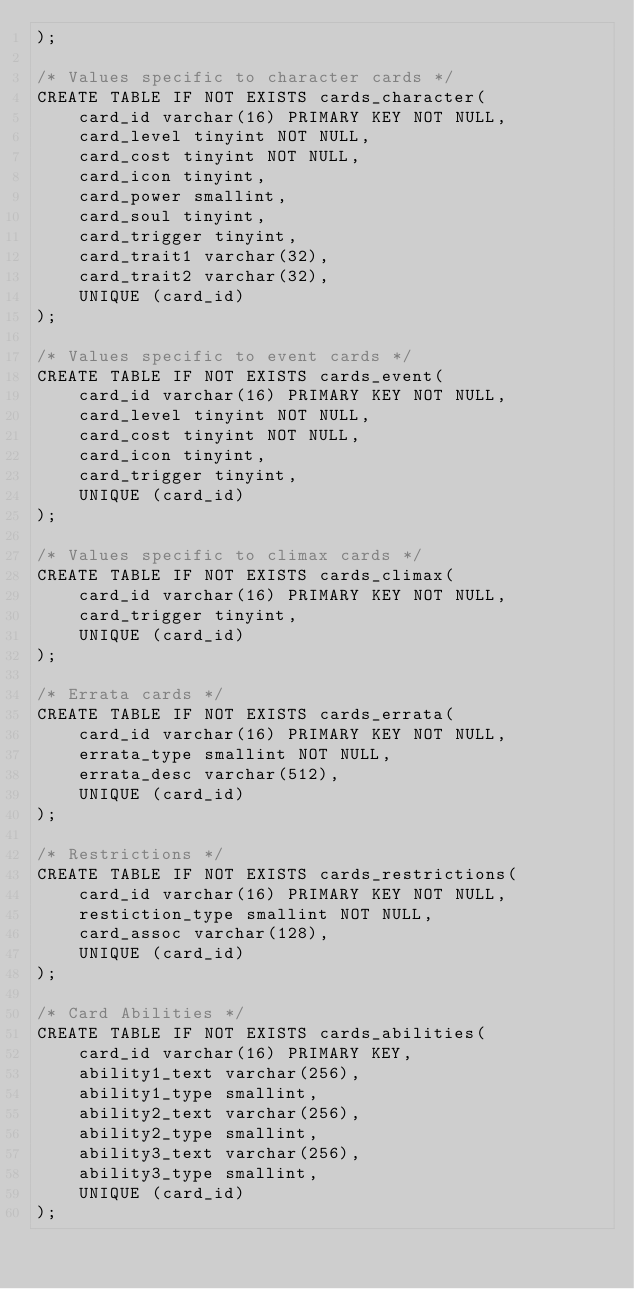Convert code to text. <code><loc_0><loc_0><loc_500><loc_500><_SQL_>);

/* Values specific to character cards */
CREATE TABLE IF NOT EXISTS cards_character(
    card_id varchar(16) PRIMARY KEY NOT NULL,
    card_level tinyint NOT NULL,
    card_cost tinyint NOT NULL,
    card_icon tinyint,
    card_power smallint,
    card_soul tinyint,
    card_trigger tinyint,
    card_trait1 varchar(32),
    card_trait2 varchar(32),
    UNIQUE (card_id)
);

/* Values specific to event cards */
CREATE TABLE IF NOT EXISTS cards_event(
    card_id varchar(16) PRIMARY KEY NOT NULL,
    card_level tinyint NOT NULL,
    card_cost tinyint NOT NULL,
    card_icon tinyint,
    card_trigger tinyint,
    UNIQUE (card_id)
);

/* Values specific to climax cards */
CREATE TABLE IF NOT EXISTS cards_climax(
    card_id varchar(16) PRIMARY KEY NOT NULL,
    card_trigger tinyint,
    UNIQUE (card_id)
);

/* Errata cards */
CREATE TABLE IF NOT EXISTS cards_errata(
	card_id varchar(16) PRIMARY KEY NOT NULL,
    errata_type smallint NOT NULL,
    errata_desc varchar(512),
    UNIQUE (card_id)
);

/* Restrictions */
CREATE TABLE IF NOT EXISTS cards_restrictions(
    card_id varchar(16) PRIMARY KEY NOT NULL,
    restiction_type smallint NOT NULL,
    card_assoc varchar(128),
    UNIQUE (card_id)
);

/* Card Abilities */
CREATE TABLE IF NOT EXISTS cards_abilities(
    card_id varchar(16) PRIMARY KEY,
    ability1_text varchar(256),
    ability1_type smallint,
    ability2_text varchar(256),
    ability2_type smallint,
    ability3_text varchar(256),
    ability3_type smallint,
    UNIQUE (card_id)
);
</code> 